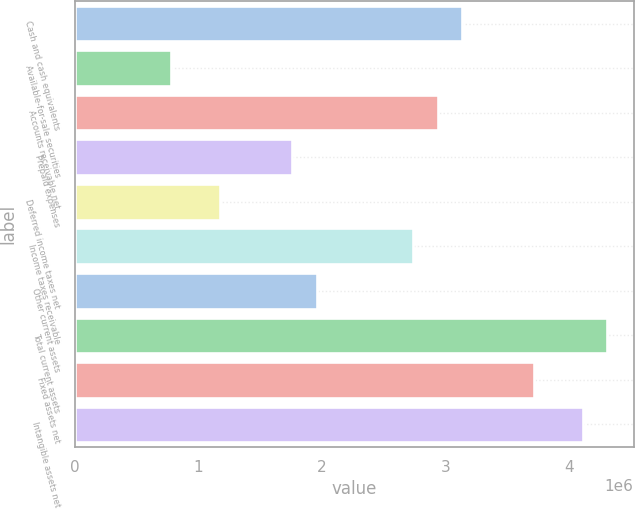Convert chart to OTSL. <chart><loc_0><loc_0><loc_500><loc_500><bar_chart><fcel>Cash and cash equivalents<fcel>Available-for-sale securities<fcel>Accounts receivable net<fcel>Prepaid expenses<fcel>Deferred income taxes net<fcel>Income taxes receivable<fcel>Other current assets<fcel>Total current assets<fcel>Fixed assets net<fcel>Intangible assets net<nl><fcel>3.1309e+06<fcel>782827<fcel>2.93522e+06<fcel>1.76119e+06<fcel>1.17417e+06<fcel>2.73955e+06<fcel>1.95686e+06<fcel>4.30493e+06<fcel>3.71791e+06<fcel>4.10926e+06<nl></chart> 